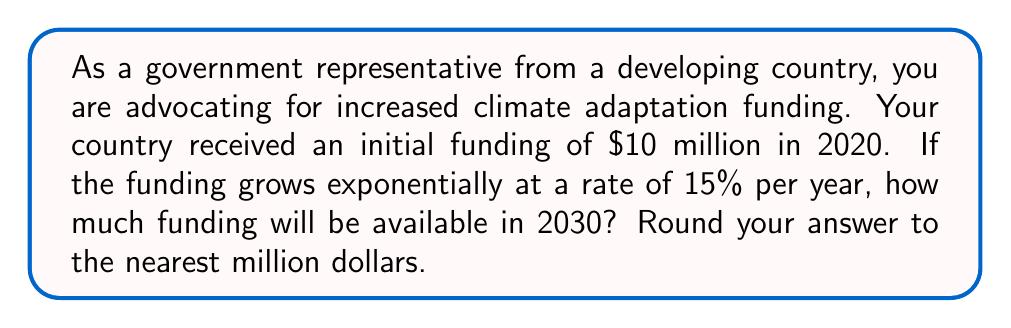Give your solution to this math problem. To solve this problem, we'll use the exponential growth formula:

$$A = P(1 + r)^t$$

Where:
$A$ = Final amount
$P$ = Initial principal balance
$r$ = Annual growth rate (as a decimal)
$t$ = Number of years

Given:
$P = 10$ million dollars
$r = 15\% = 0.15$
$t = 2030 - 2020 = 10$ years

Let's substitute these values into the formula:

$$A = 10,000,000(1 + 0.15)^{10}$$

Now, let's calculate step by step:

1) First, calculate $(1 + 0.15)^{10}$:
   $$(1.15)^{10} = 4.0456$$

2) Multiply this by the initial amount:
   $$10,000,000 \times 4.0456 = 40,456,000$$

3) Round to the nearest million:
   $$40,456,000 \approx 40,000,000$$

Therefore, the funding available in 2030 will be approximately $40 million.
Answer: $40 million 